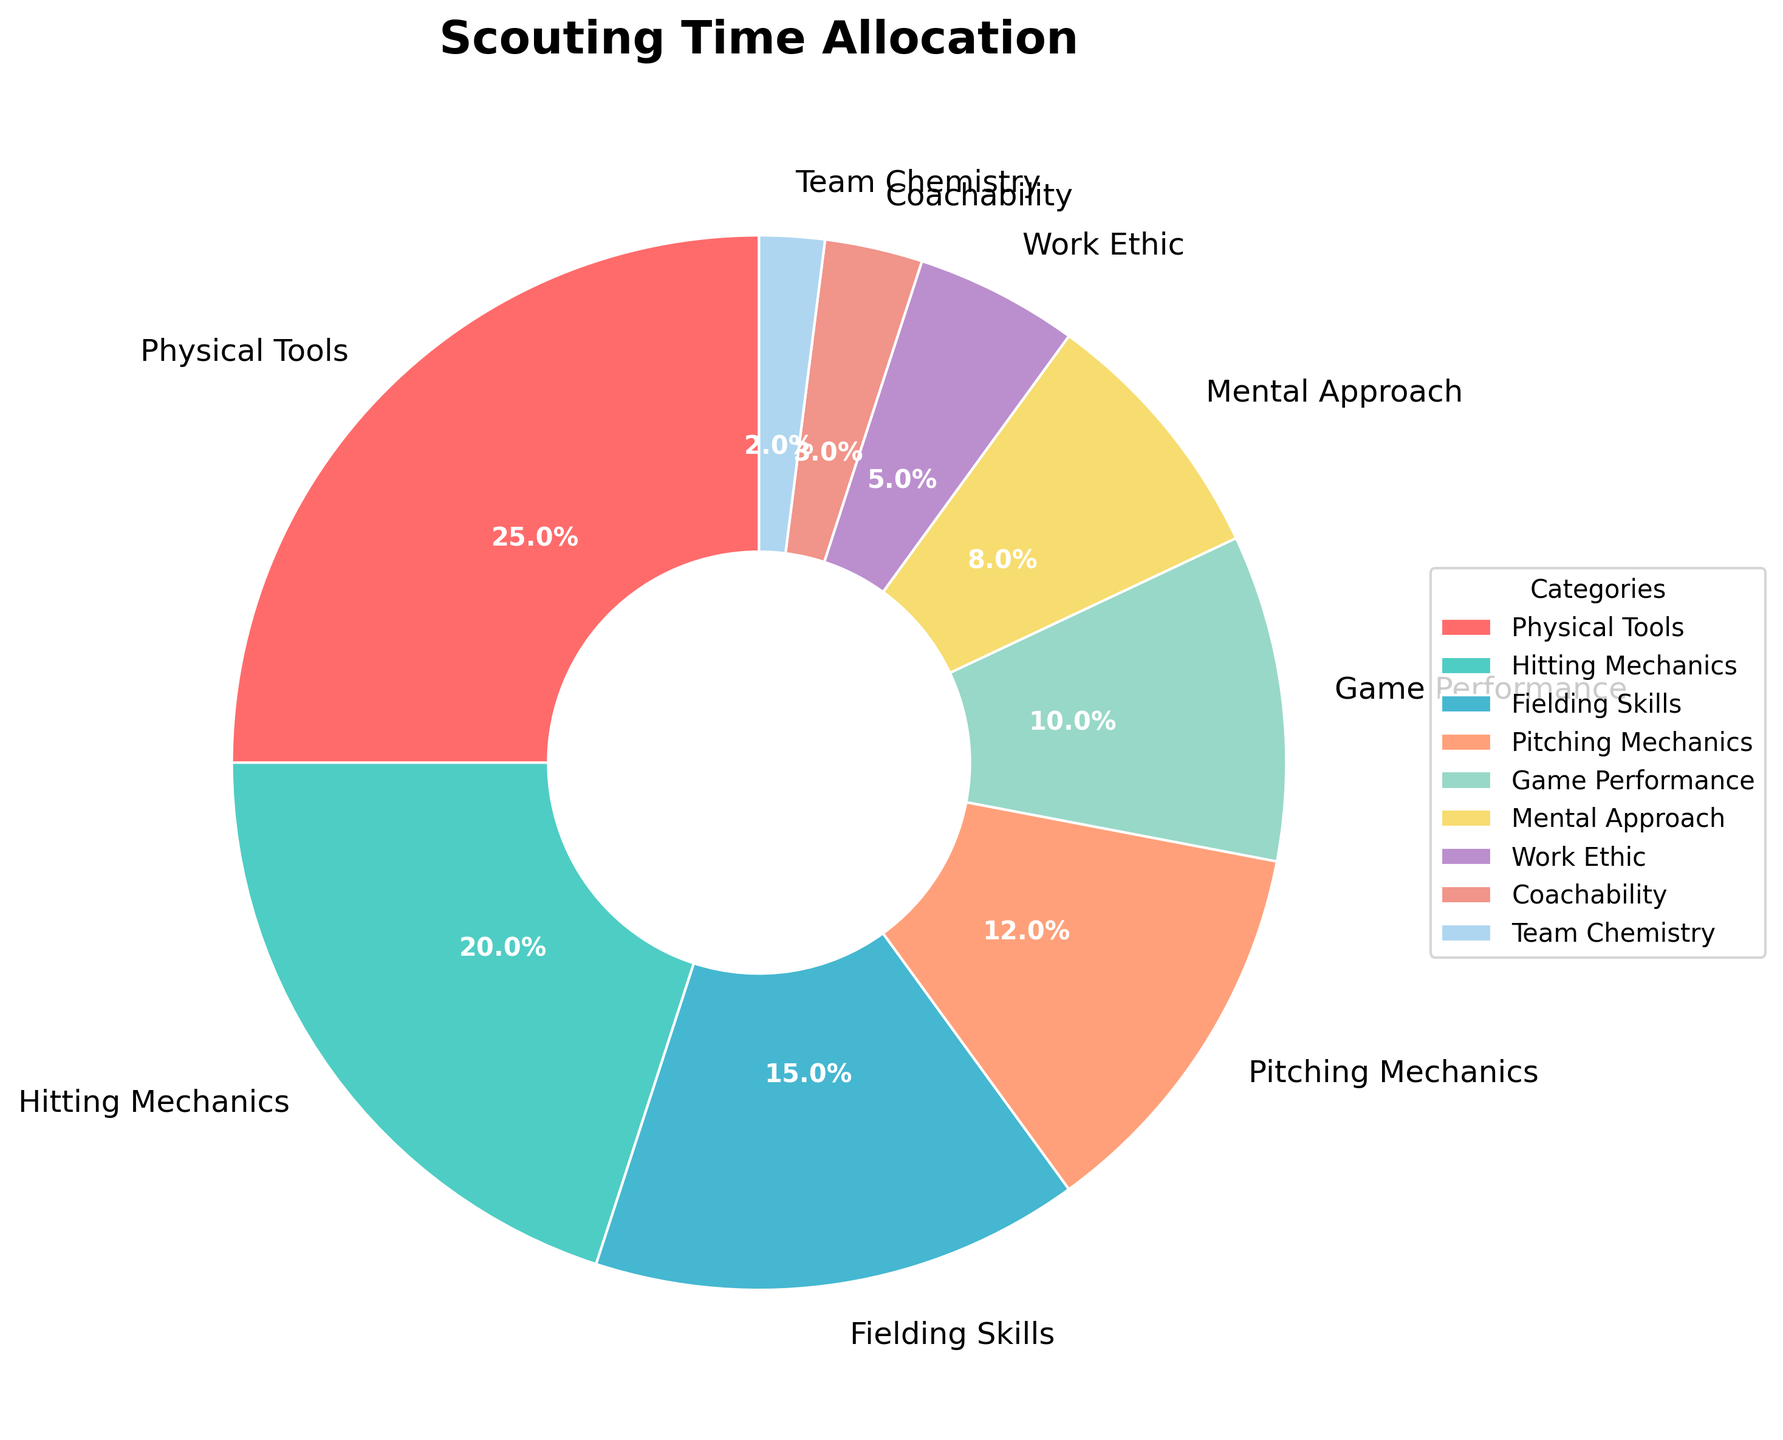Which category has the highest percentage of scouting time allocation? The slice representing 'Physical Tools' is the largest, indicating the highest time allocation at 25%.
Answer: Physical Tools Which category has the smallest percentage of scouting time allocation? The slice for 'Team Chemistry' is the smallest, indicating the lowest allocation at 2%.
Answer: Team Chemistry What is the combined percentage of time allocated to Hitting Mechanics and Pitching Mechanics? Sum the percentages of 'Hitting Mechanics' (20%) and 'Pitching Mechanics' (12%): 20% + 12% = 32%
Answer: 32% Which categories together make up less than 10% of the scouting time allocation? The slices for 'Work Ethic' (5%), 'Coachability' (3%), and 'Team Chemistry' (2%) together total 5% + 3% + 2% = 10%, where the portion for 'Coachability' and 'Team Chemistry' individually are less than 10%.
Answer: Coachability and Team Chemistry How does the time allocation for Fielding Skills compare to that for Game Performance? 'Fielding Skills' has a larger slice (15%) compared to 'Game Performance' (10%), indicating a greater allocation to fielding.
Answer: Fielding Skills What is the average percentage of time allocated to Mental Approach and Work Ethic? Sum the percentages of 'Mental Approach' (8%) and 'Work Ethic' (5%) and divide by 2: (8% + 5%) / 2 = 6.5%
Answer: 6.5% Does the category 'Pitching Mechanics' have a higher or lower allocation than 'Hitting Mechanics'? 'Pitching Mechanics' has a slice of 12%, while 'Hitting Mechanics' has 20%, indicating 'Pitching Mechanics' has a lower allocation.
Answer: Lower List the categories whose percentages individually exceed 10%. The slices for 'Physical Tools' (25%), 'Hitting Mechanics' (20%), 'Fielding Skills' (15%), and 'Pitching Mechanics' (12%) all exceed 10%.
Answer: Physical Tools, Hitting Mechanics, Fielding Skills, Pitching Mechanics What percentage of the scouting time is allocated to aspects other than Physical Tools? Subtract the percentage of 'Physical Tools' (25%) from 100%: 100% - 25% = 75%
Answer: 75% 